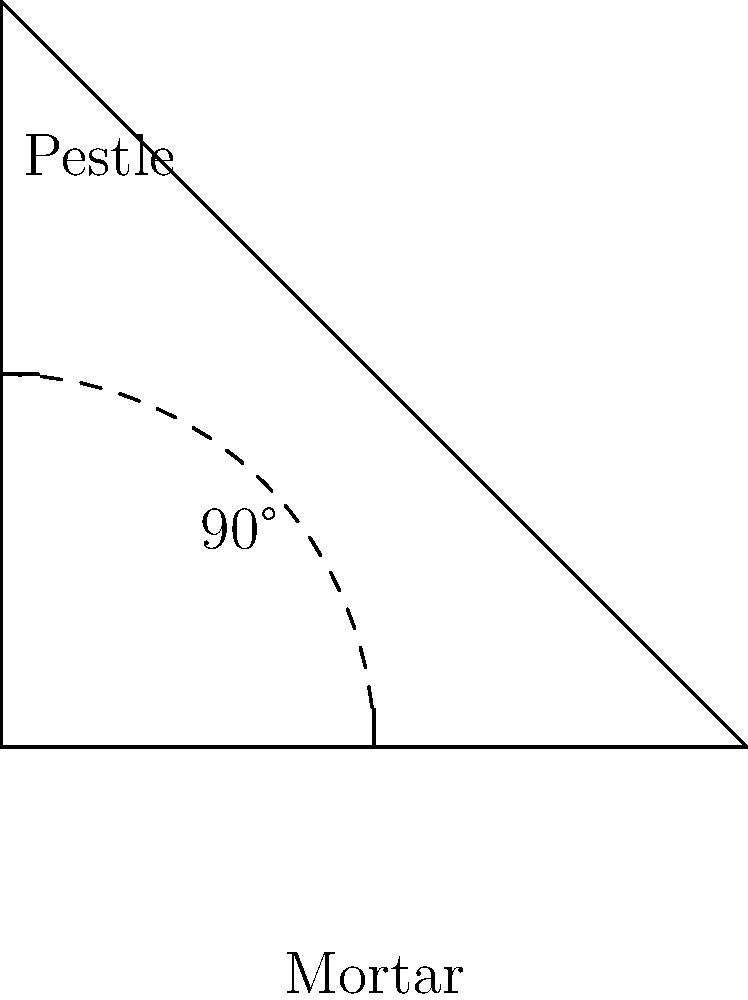In a traditional Indian mortar and pestle set, the pestle is typically held at what angle relative to the mortar's surface for optimal spice grinding efficiency? To understand the optimal angle for using a mortar and pestle in Indian spice grinding, let's consider the following steps:

1. The mortar is the bowl-like structure that holds the spices.
2. The pestle is the grinding tool used to crush and grind the spices against the mortar's surface.
3. The angle between the pestle and the mortar's surface is crucial for efficient grinding.
4. A 90-degree angle (perpendicular) provides the most direct force but less grinding action.
5. A very shallow angle (close to parallel) provides more grinding action but less crushing force.
6. The optimal angle balances direct force and grinding action.
7. In traditional Indian spice grinding techniques, the pestle is typically held at around a 45-degree angle to the mortar's surface.
8. This 45-degree angle allows for:
   a. Sufficient downward force to crush hard spices
   b. Adequate sliding motion to grind and mix the spices
   c. Efficient release of essential oils and flavors from the spices
9. The 45-degree angle also allows for a comfortable grip and arm position during the grinding process.

Therefore, the optimal angle for efficient spice grinding using a traditional Indian mortar and pestle is approximately 45 degrees.
Answer: 45 degrees 